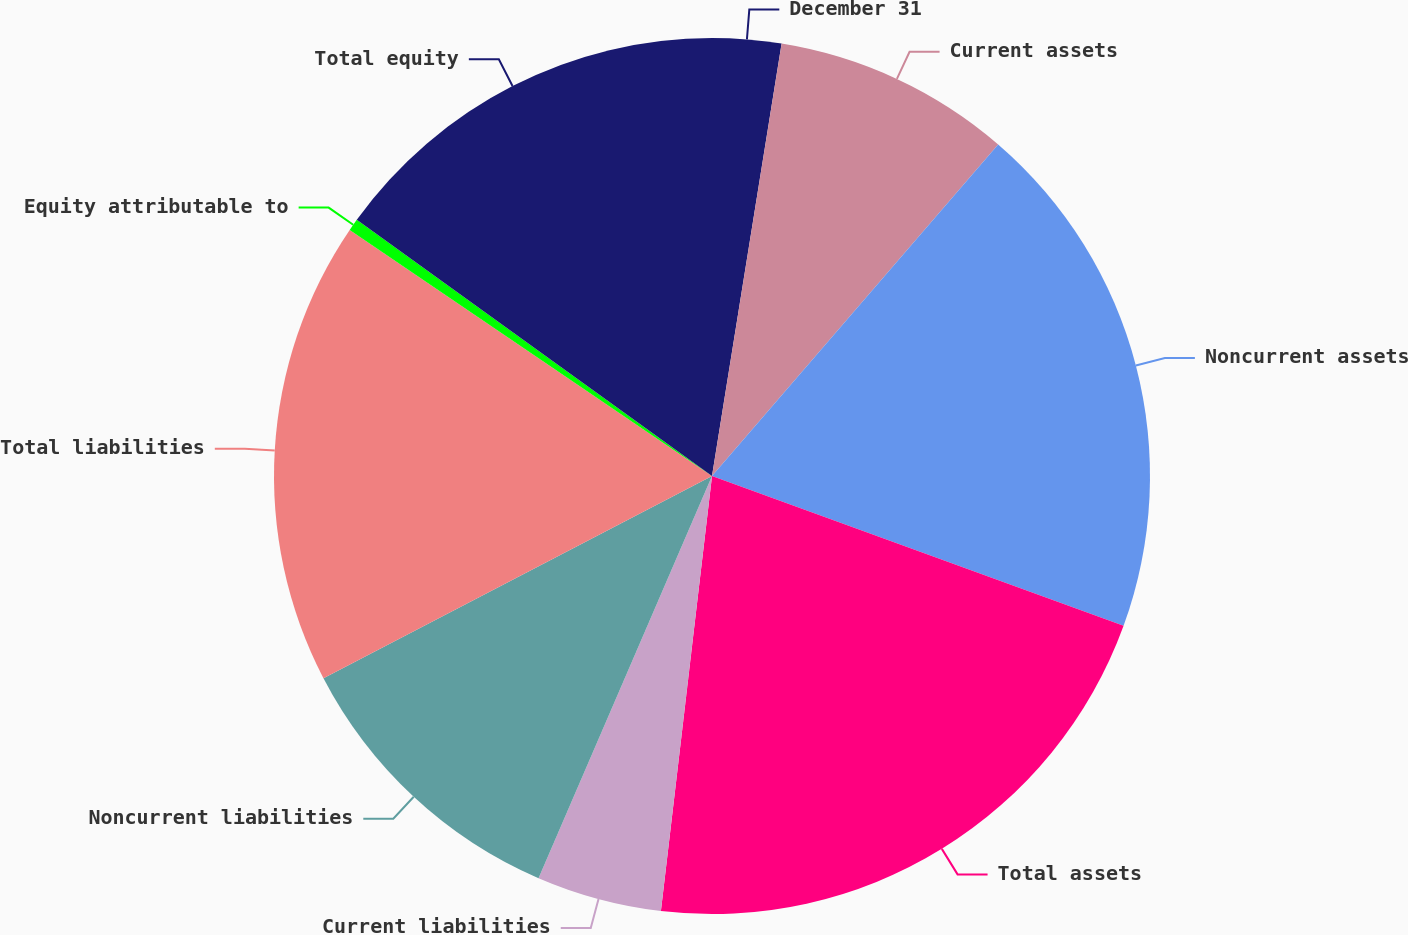<chart> <loc_0><loc_0><loc_500><loc_500><pie_chart><fcel>December 31<fcel>Current assets<fcel>Noncurrent assets<fcel>Total assets<fcel>Current liabilities<fcel>Noncurrent liabilities<fcel>Total liabilities<fcel>Equity attributable to<fcel>Total equity<nl><fcel>2.54%<fcel>8.79%<fcel>19.22%<fcel>21.3%<fcel>4.62%<fcel>10.88%<fcel>17.13%<fcel>0.45%<fcel>15.05%<nl></chart> 